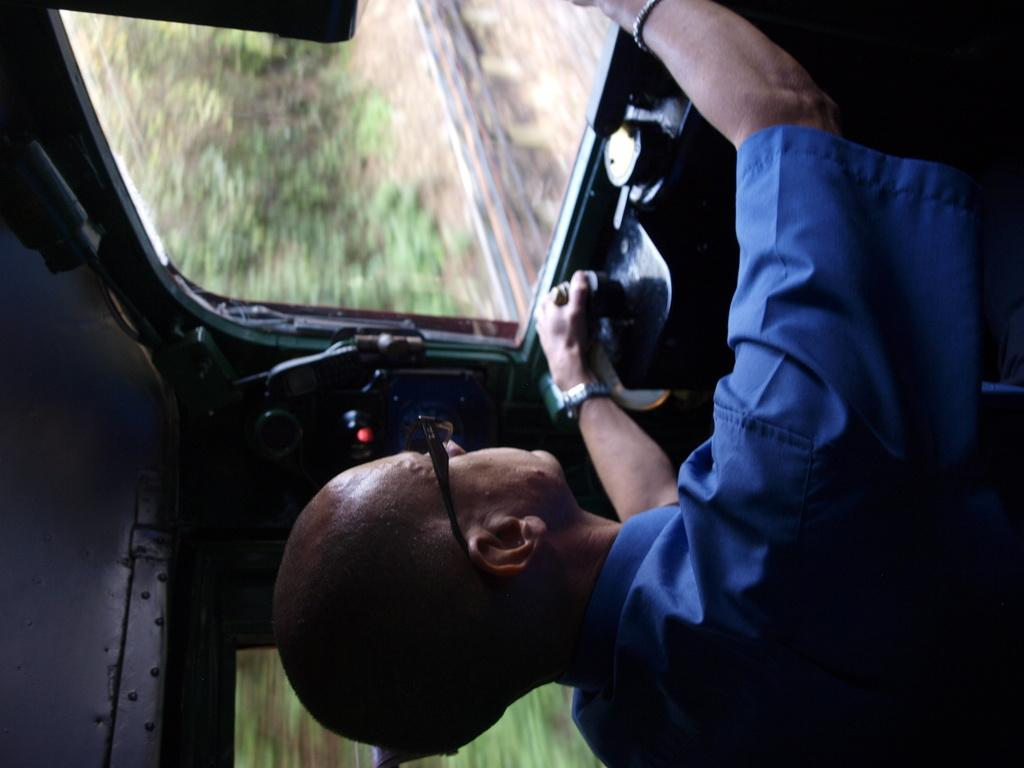What is the setting of the image? The image is taken inside a vehicle. Who is present in the vehicle? There is a person in the vehicle. What is the person wearing? The person is wearing a blue shirt. What is the person doing in the vehicle? The person is driving the vehicle. What can be seen outside the vehicle? There are trees visible behind the vehicle. Where are the trees located? The trees are on the land. How many pairs of shoes can be seen in the image? There are no shoes visible in the image. What is the tendency of the boys in the image? There are no boys present in the image. 